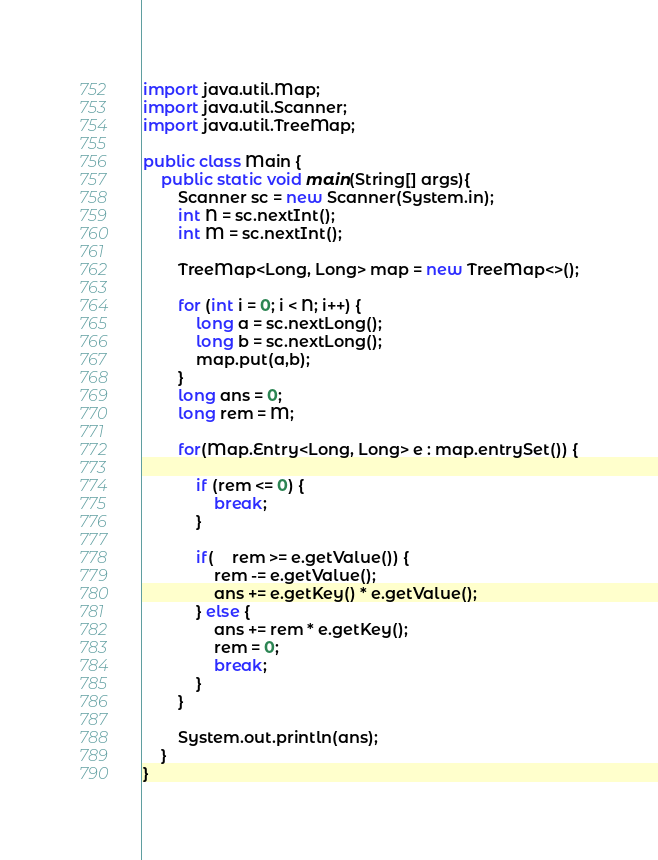<code> <loc_0><loc_0><loc_500><loc_500><_Java_>import java.util.Map;
import java.util.Scanner;
import java.util.TreeMap;

public class Main {
 	public static void main(String[] args){
 		Scanner sc = new Scanner(System.in);
 		int N = sc.nextInt();
 		int M = sc.nextInt();

 		TreeMap<Long, Long> map = new TreeMap<>();

 		for (int i = 0; i < N; i++) {
 			long a = sc.nextLong();
 			long b = sc.nextLong();
 			map.put(a,b);
 		}
 		long ans = 0;
 		long rem = M;

		for(Map.Entry<Long, Long> e : map.entrySet()) {

			if (rem <= 0) {
				break;
			}

			if(	rem >= e.getValue()) {
				rem -= e.getValue();
				ans += e.getKey() * e.getValue();
			} else {
				ans += rem * e.getKey();
				rem = 0;
				break;
			}
		}

		System.out.println(ans);
 	}
}
</code> 